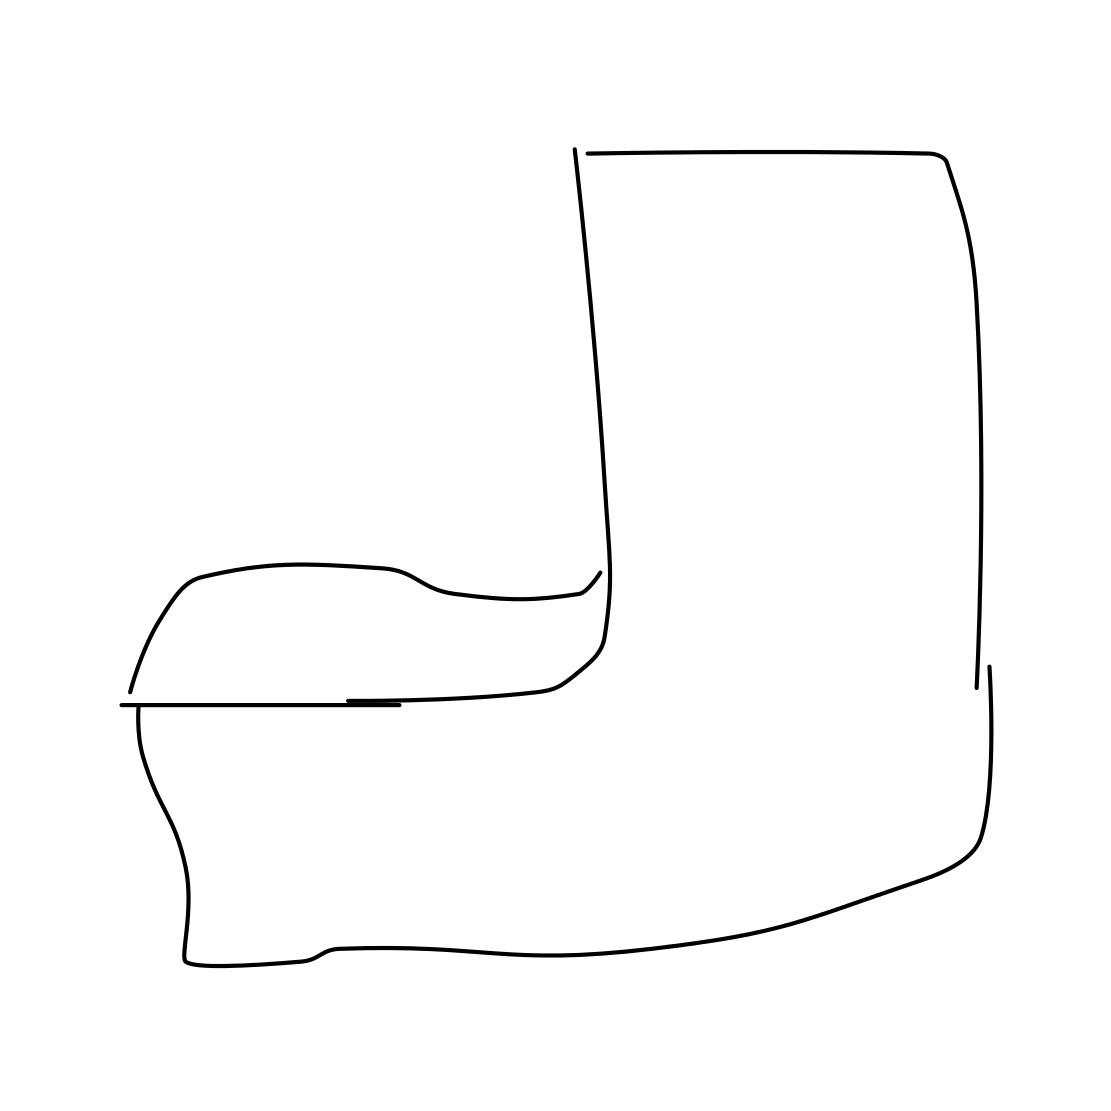How would you describe the comfort level of this armchair based on its design? Based on its sleek silhouette, the armchair's comfort may be more aesthetic than plush. The line drawing suggests an emphasis on clean design rather than cushioning. For added comfort, one might consider additional pillows or throws. Is there any indication of the materials used for this armchair? The image doesn't provide detail that specifies materials, but the streamlined design could be indicative of metal, wood, or molded plastic construction, which are common in minimalist furniture. 